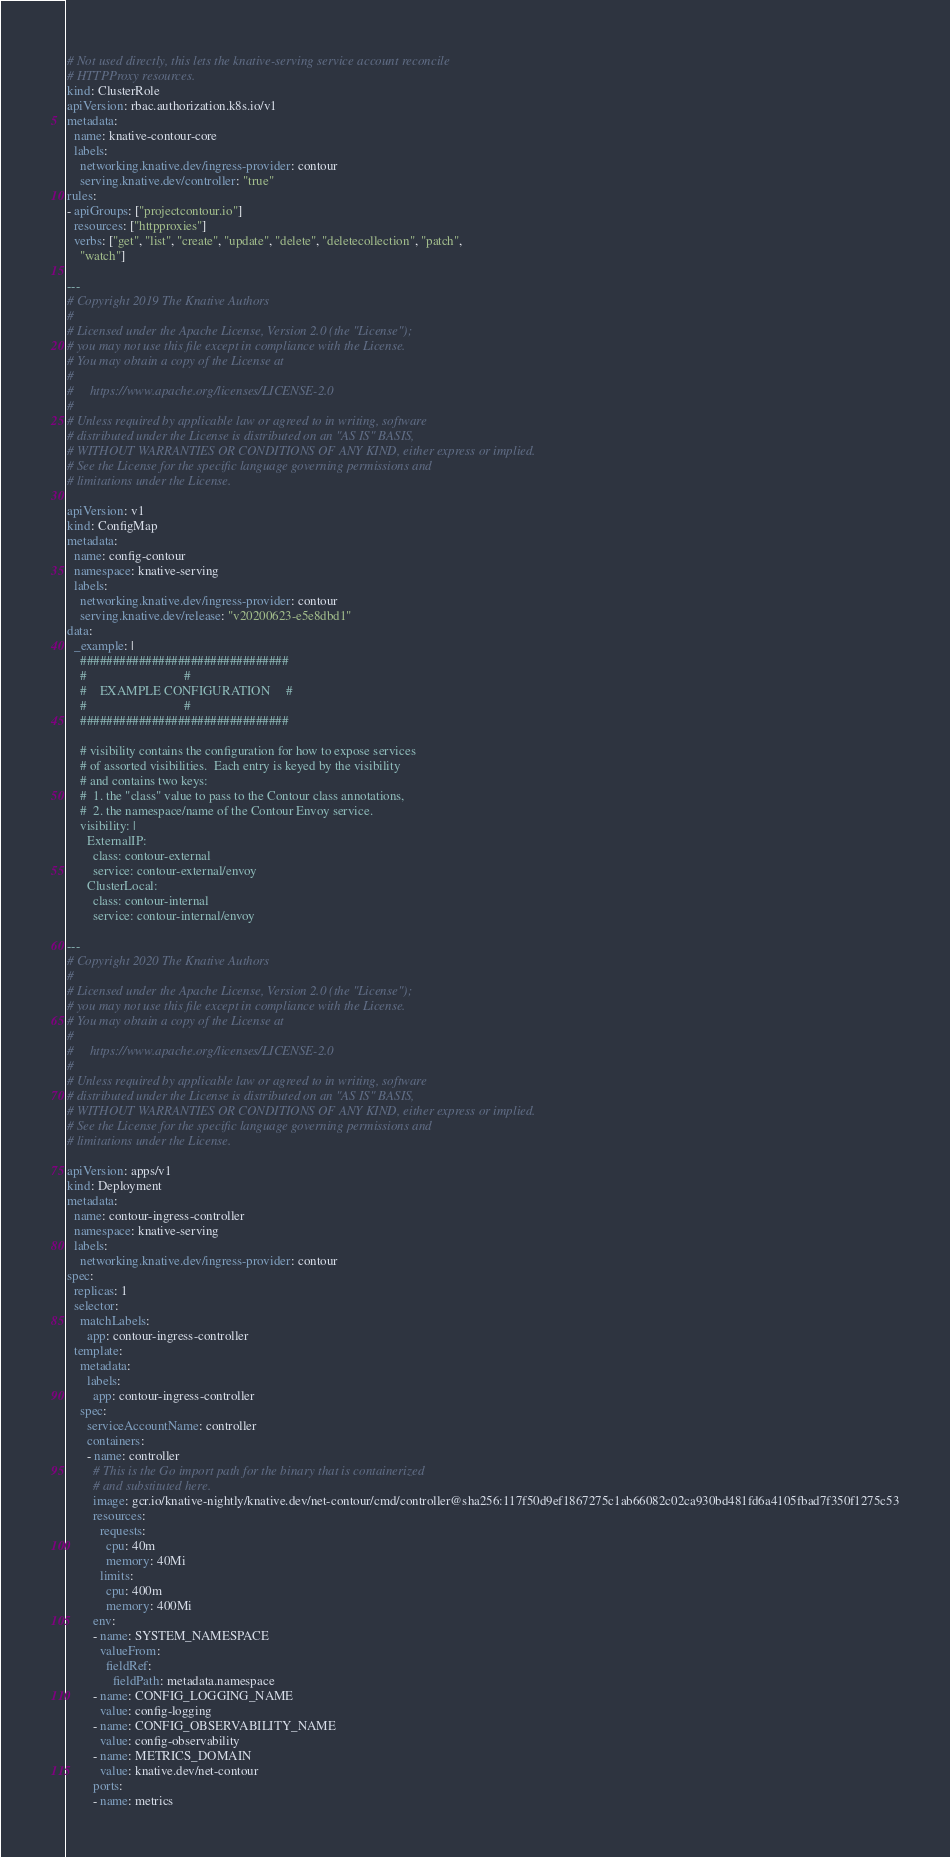<code> <loc_0><loc_0><loc_500><loc_500><_YAML_># Not used directly, this lets the knative-serving service account reconcile
# HTTPProxy resources.
kind: ClusterRole
apiVersion: rbac.authorization.k8s.io/v1
metadata:
  name: knative-contour-core
  labels:
    networking.knative.dev/ingress-provider: contour
    serving.knative.dev/controller: "true"
rules:
- apiGroups: ["projectcontour.io"]
  resources: ["httpproxies"]
  verbs: ["get", "list", "create", "update", "delete", "deletecollection", "patch",
    "watch"]

---
# Copyright 2019 The Knative Authors
#
# Licensed under the Apache License, Version 2.0 (the "License");
# you may not use this file except in compliance with the License.
# You may obtain a copy of the License at
#
#     https://www.apache.org/licenses/LICENSE-2.0
#
# Unless required by applicable law or agreed to in writing, software
# distributed under the License is distributed on an "AS IS" BASIS,
# WITHOUT WARRANTIES OR CONDITIONS OF ANY KIND, either express or implied.
# See the License for the specific language governing permissions and
# limitations under the License.

apiVersion: v1
kind: ConfigMap
metadata:
  name: config-contour
  namespace: knative-serving
  labels:
    networking.knative.dev/ingress-provider: contour
    serving.knative.dev/release: "v20200623-e5e8dbd1"
data:
  _example: |
    ################################
    #                              #
    #    EXAMPLE CONFIGURATION     #
    #                              #
    ################################

    # visibility contains the configuration for how to expose services
    # of assorted visibilities.  Each entry is keyed by the visibility
    # and contains two keys:
    #  1. the "class" value to pass to the Contour class annotations,
    #  2. the namespace/name of the Contour Envoy service.
    visibility: |
      ExternalIP:
        class: contour-external
        service: contour-external/envoy
      ClusterLocal:
        class: contour-internal
        service: contour-internal/envoy

---
# Copyright 2020 The Knative Authors
#
# Licensed under the Apache License, Version 2.0 (the "License");
# you may not use this file except in compliance with the License.
# You may obtain a copy of the License at
#
#     https://www.apache.org/licenses/LICENSE-2.0
#
# Unless required by applicable law or agreed to in writing, software
# distributed under the License is distributed on an "AS IS" BASIS,
# WITHOUT WARRANTIES OR CONDITIONS OF ANY KIND, either express or implied.
# See the License for the specific language governing permissions and
# limitations under the License.

apiVersion: apps/v1
kind: Deployment
metadata:
  name: contour-ingress-controller
  namespace: knative-serving
  labels:
    networking.knative.dev/ingress-provider: contour
spec:
  replicas: 1
  selector:
    matchLabels:
      app: contour-ingress-controller
  template:
    metadata:
      labels:
        app: contour-ingress-controller
    spec:
      serviceAccountName: controller
      containers:
      - name: controller
        # This is the Go import path for the binary that is containerized
        # and substituted here.
        image: gcr.io/knative-nightly/knative.dev/net-contour/cmd/controller@sha256:117f50d9ef1867275c1ab66082c02ca930bd481fd6a4105fbad7f350f1275c53
        resources:
          requests:
            cpu: 40m
            memory: 40Mi
          limits:
            cpu: 400m
            memory: 400Mi
        env:
        - name: SYSTEM_NAMESPACE
          valueFrom:
            fieldRef:
              fieldPath: metadata.namespace
        - name: CONFIG_LOGGING_NAME
          value: config-logging
        - name: CONFIG_OBSERVABILITY_NAME
          value: config-observability
        - name: METRICS_DOMAIN
          value: knative.dev/net-contour
        ports:
        - name: metrics</code> 